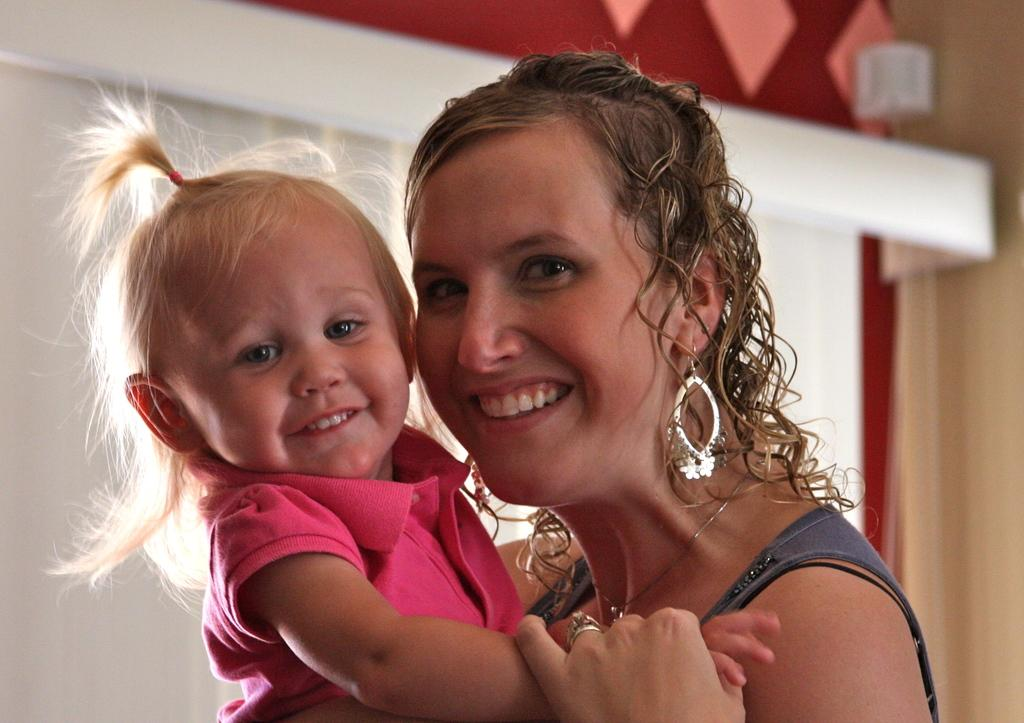Who is the main subject in the image? There is a woman in the image. What is the woman wearing? The woman is wearing a black dress. What is the woman's facial expression? The woman is smiling. What is the woman holding in the image? The woman is holding a baby. What is the baby wearing? The baby is wearing a pink dress. How would you describe the background of the image? The background of the image is blurry. What type of plant can be seen growing in the woman's hair in the image? There is no plant visible in the woman's hair in the image. What kind of tin is the baby holding in the image? There is no tin present in the image; the baby is not holding anything. 